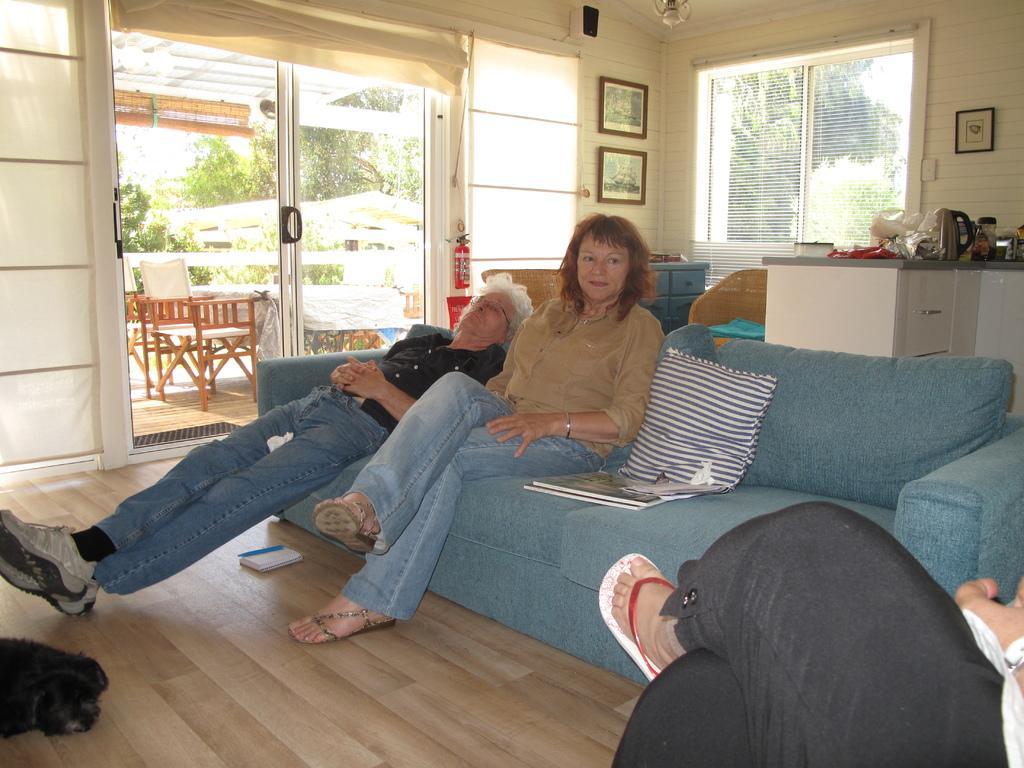Describe this image in one or two sentences. In this image I can see two women are sitting on a sofa. Here I can see a leg of a person. I can also see few chairs and number of trees. 